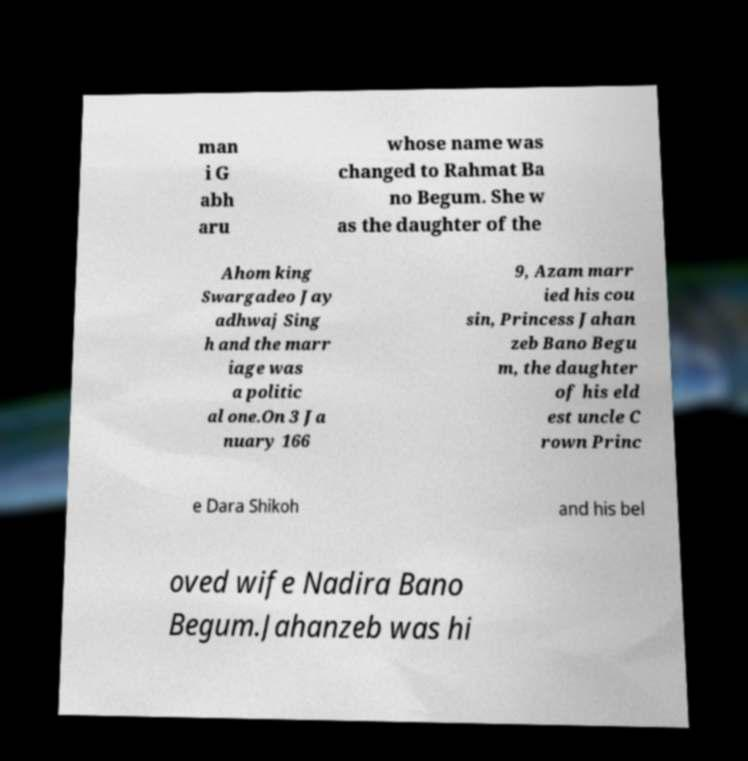I need the written content from this picture converted into text. Can you do that? man i G abh aru whose name was changed to Rahmat Ba no Begum. She w as the daughter of the Ahom king Swargadeo Jay adhwaj Sing h and the marr iage was a politic al one.On 3 Ja nuary 166 9, Azam marr ied his cou sin, Princess Jahan zeb Bano Begu m, the daughter of his eld est uncle C rown Princ e Dara Shikoh and his bel oved wife Nadira Bano Begum.Jahanzeb was hi 